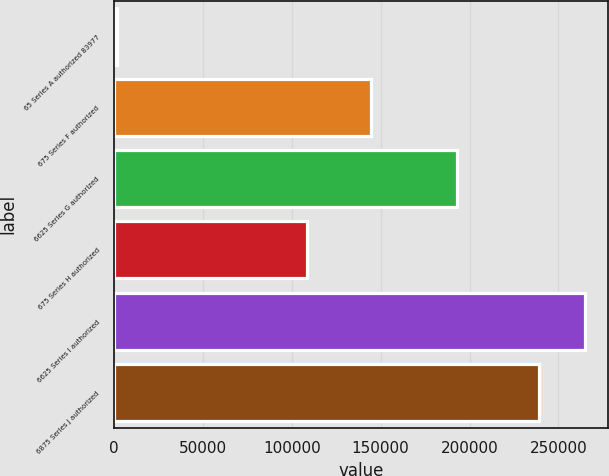Convert chart to OTSL. <chart><loc_0><loc_0><loc_500><loc_500><bar_chart><fcel>65 Series A authorized 83977<fcel>675 Series F authorized<fcel>6625 Series G authorized<fcel>675 Series H authorized<fcel>6625 Series I authorized<fcel>6875 Series J authorized<nl><fcel>1787<fcel>144720<fcel>193135<fcel>108549<fcel>264901<fcel>238842<nl></chart> 